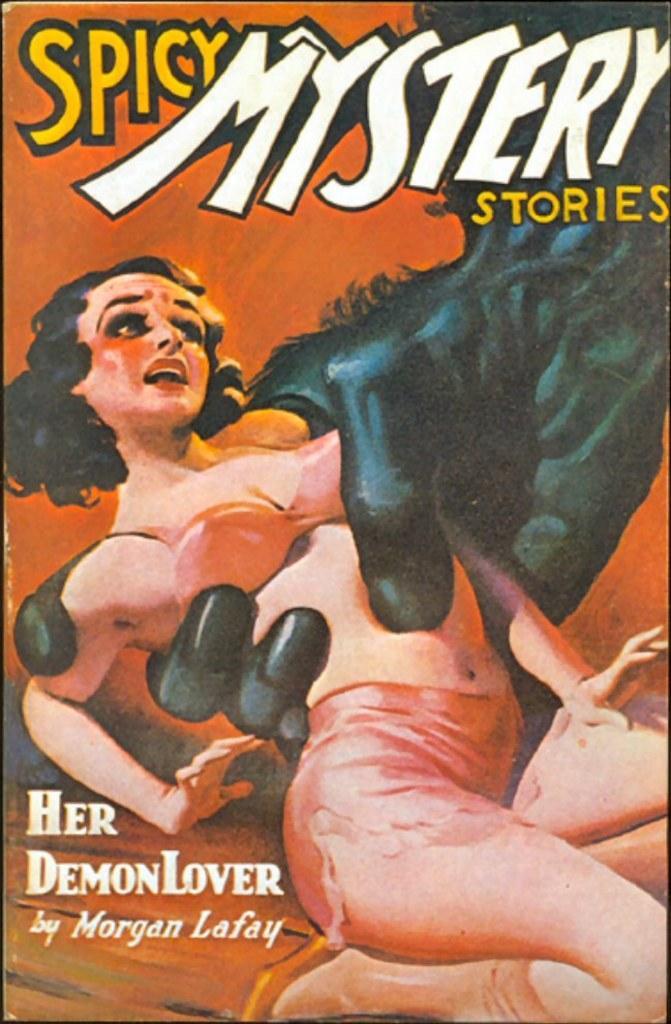Describe this image in one or two sentences. In this image I can see the cover page of the book which is orange in color on which I can see a huge black colored hand is holding a woman. I can see few words written on the page. 